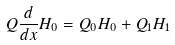<formula> <loc_0><loc_0><loc_500><loc_500>Q \frac { d } { d x } H _ { 0 } = Q _ { 0 } H _ { 0 } + Q _ { 1 } H _ { 1 }</formula> 